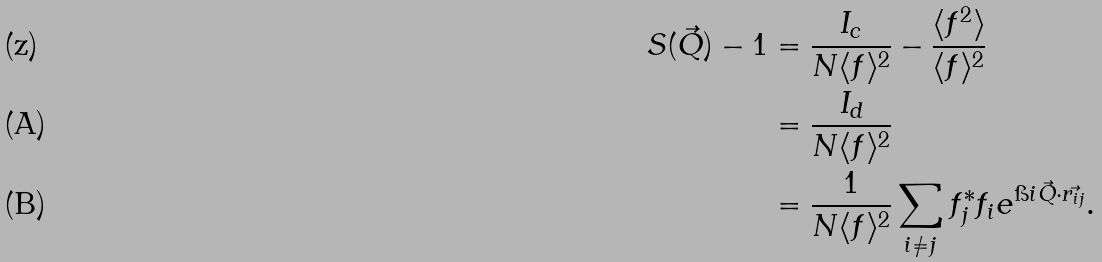<formula> <loc_0><loc_0><loc_500><loc_500>S ( \vec { Q } ) - 1 & = \frac { I _ { c } } { N \langle f \rangle ^ { 2 } } - \frac { \langle f ^ { 2 } \rangle } { \langle f \rangle ^ { 2 } } \\ & = \frac { I _ { d } } { N \langle f \rangle ^ { 2 } } \\ & = \frac { 1 } { N \langle f \rangle ^ { 2 } } \sum _ { i \neq j } f _ { j } ^ { * } f _ { i } e ^ { \i i \vec { Q } \cdot \vec { r _ { i j } } } .</formula> 